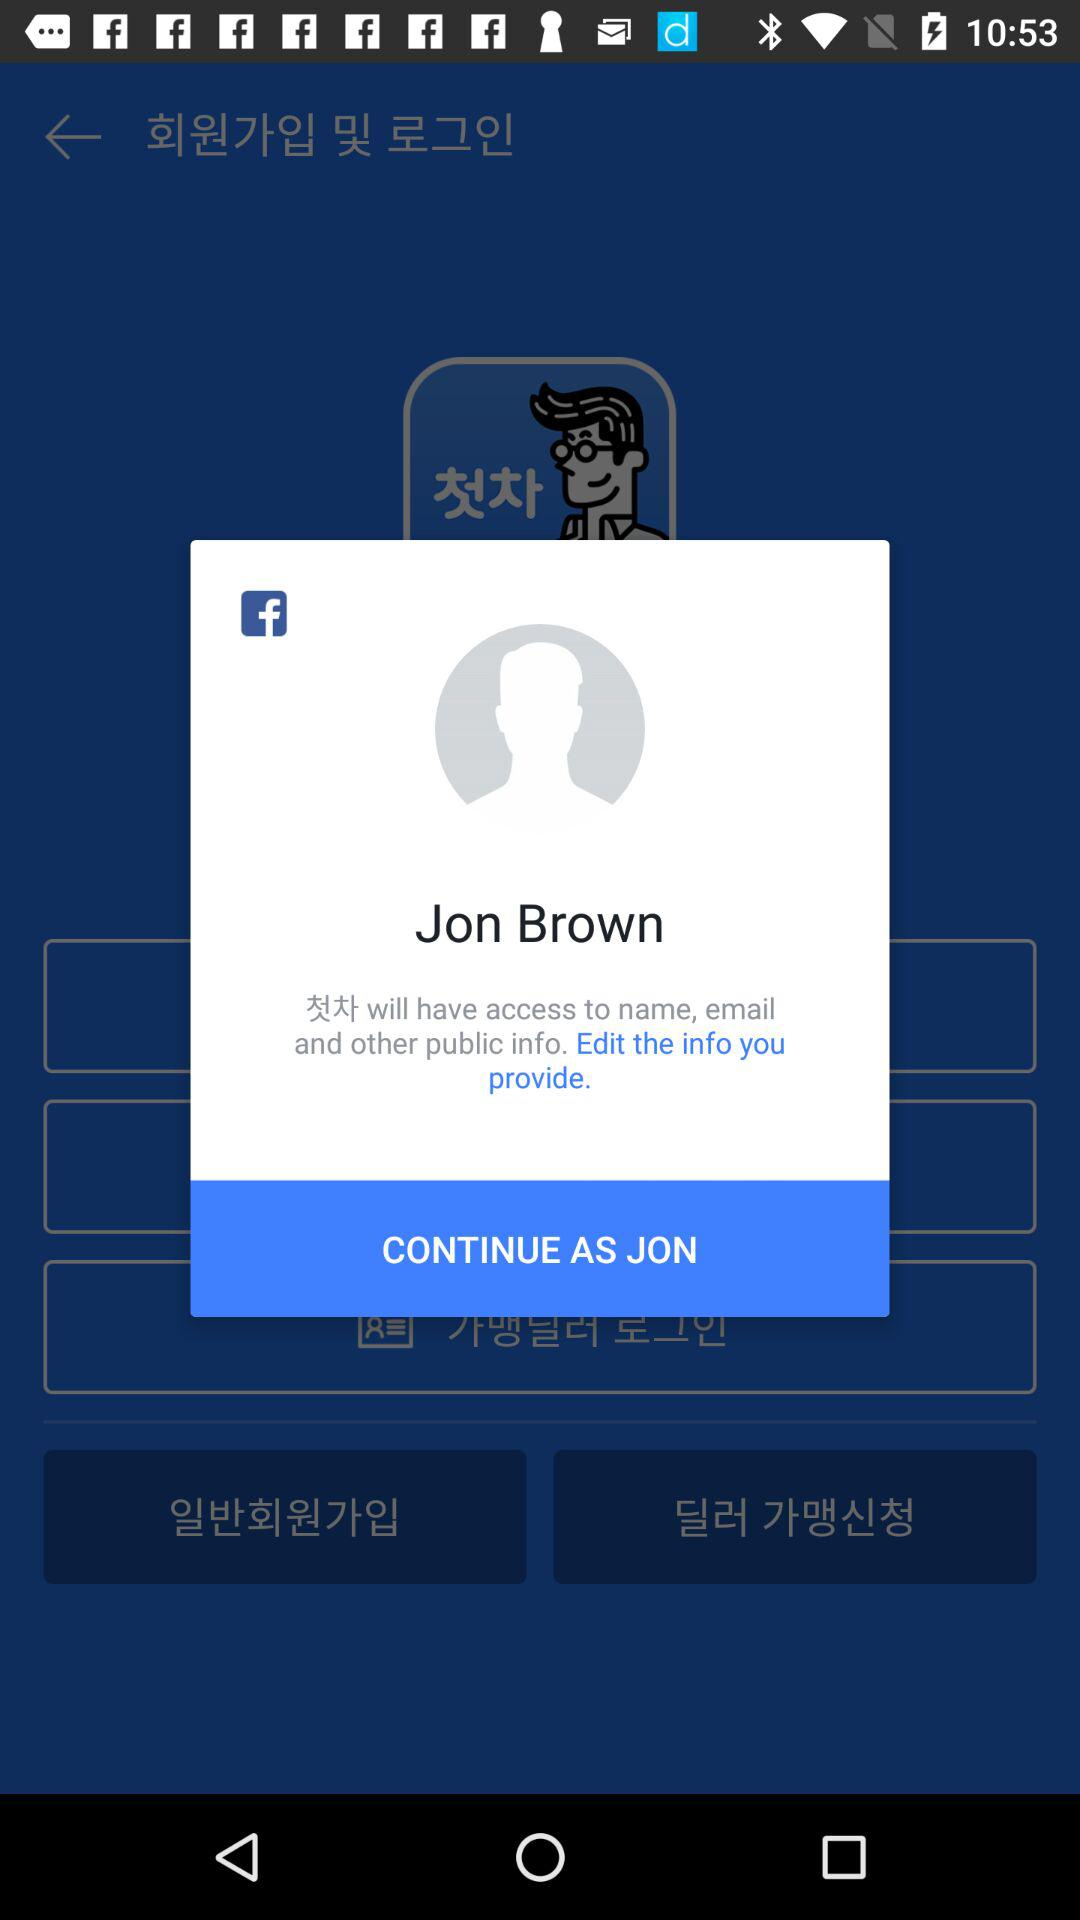What is the user name? The user name is Jon Brown. 